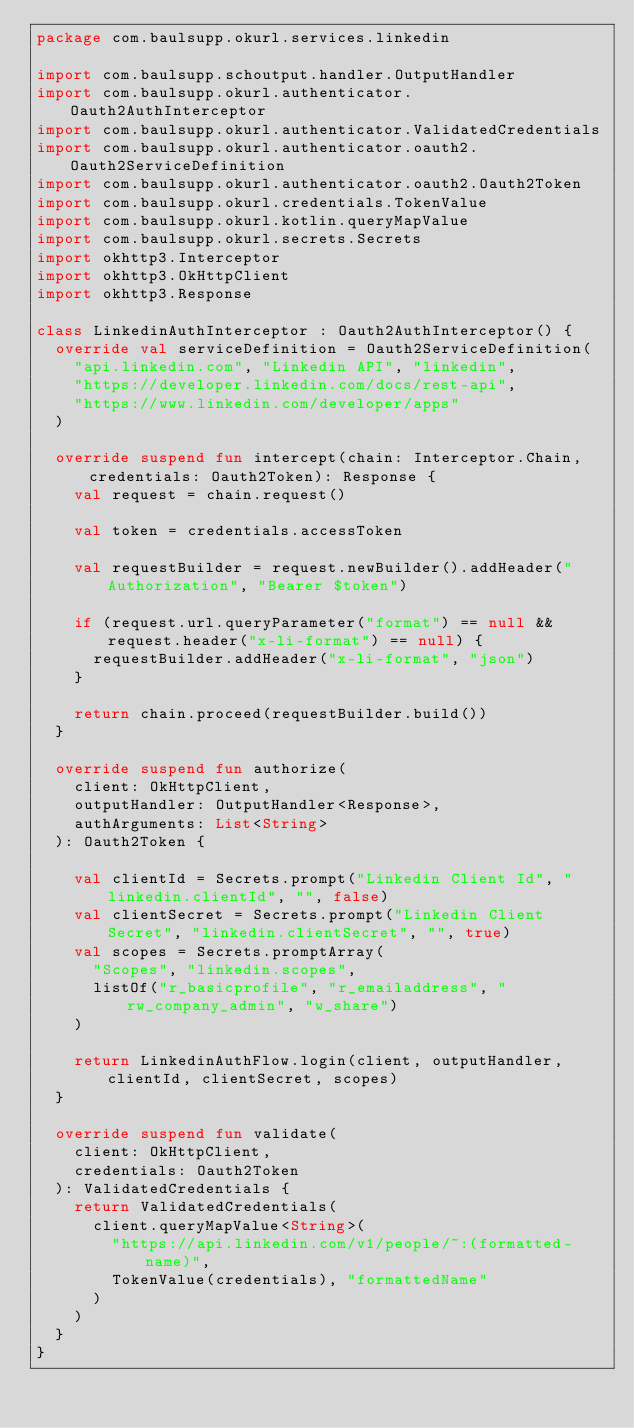<code> <loc_0><loc_0><loc_500><loc_500><_Kotlin_>package com.baulsupp.okurl.services.linkedin

import com.baulsupp.schoutput.handler.OutputHandler
import com.baulsupp.okurl.authenticator.Oauth2AuthInterceptor
import com.baulsupp.okurl.authenticator.ValidatedCredentials
import com.baulsupp.okurl.authenticator.oauth2.Oauth2ServiceDefinition
import com.baulsupp.okurl.authenticator.oauth2.Oauth2Token
import com.baulsupp.okurl.credentials.TokenValue
import com.baulsupp.okurl.kotlin.queryMapValue
import com.baulsupp.okurl.secrets.Secrets
import okhttp3.Interceptor
import okhttp3.OkHttpClient
import okhttp3.Response

class LinkedinAuthInterceptor : Oauth2AuthInterceptor() {
  override val serviceDefinition = Oauth2ServiceDefinition(
    "api.linkedin.com", "Linkedin API", "linkedin",
    "https://developer.linkedin.com/docs/rest-api",
    "https://www.linkedin.com/developer/apps"
  )

  override suspend fun intercept(chain: Interceptor.Chain, credentials: Oauth2Token): Response {
    val request = chain.request()

    val token = credentials.accessToken

    val requestBuilder = request.newBuilder().addHeader("Authorization", "Bearer $token")

    if (request.url.queryParameter("format") == null && request.header("x-li-format") == null) {
      requestBuilder.addHeader("x-li-format", "json")
    }

    return chain.proceed(requestBuilder.build())
  }

  override suspend fun authorize(
    client: OkHttpClient,
    outputHandler: OutputHandler<Response>,
    authArguments: List<String>
  ): Oauth2Token {

    val clientId = Secrets.prompt("Linkedin Client Id", "linkedin.clientId", "", false)
    val clientSecret = Secrets.prompt("Linkedin Client Secret", "linkedin.clientSecret", "", true)
    val scopes = Secrets.promptArray(
      "Scopes", "linkedin.scopes",
      listOf("r_basicprofile", "r_emailaddress", "rw_company_admin", "w_share")
    )

    return LinkedinAuthFlow.login(client, outputHandler, clientId, clientSecret, scopes)
  }

  override suspend fun validate(
    client: OkHttpClient,
    credentials: Oauth2Token
  ): ValidatedCredentials {
    return ValidatedCredentials(
      client.queryMapValue<String>(
        "https://api.linkedin.com/v1/people/~:(formatted-name)",
        TokenValue(credentials), "formattedName"
      )
    )
  }
}
</code> 